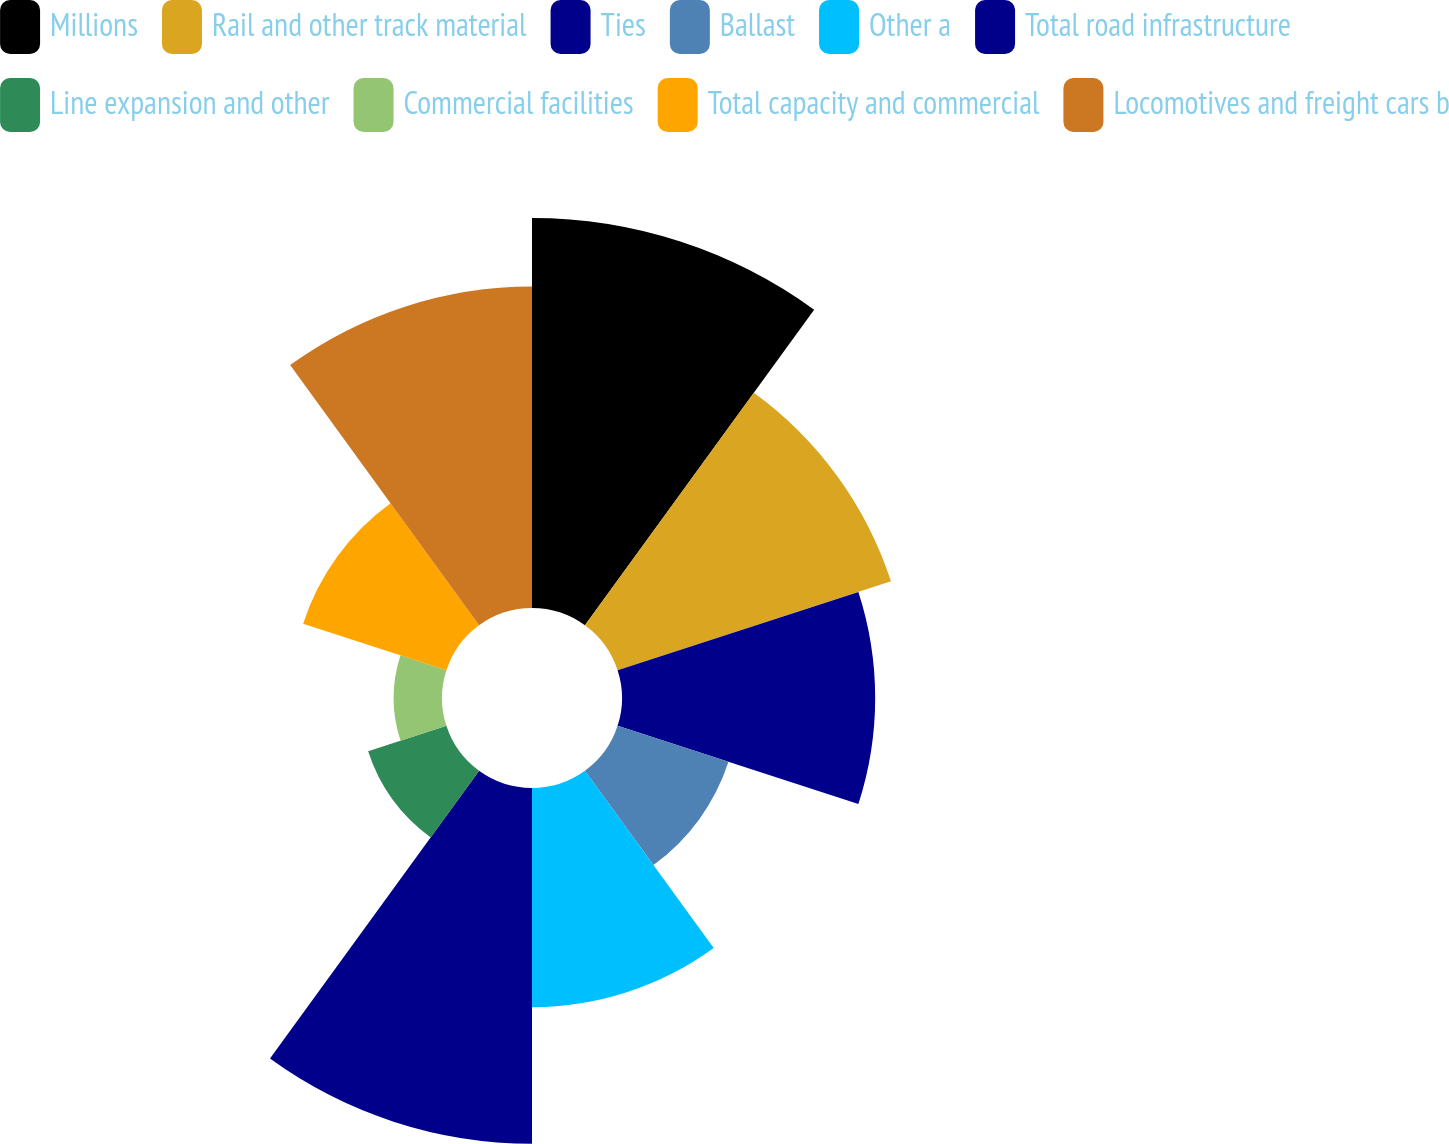<chart> <loc_0><loc_0><loc_500><loc_500><pie_chart><fcel>Millions<fcel>Rail and other track material<fcel>Ties<fcel>Ballast<fcel>Other a<fcel>Total road infrastructure<fcel>Line expansion and other<fcel>Commercial facilities<fcel>Total capacity and commercial<fcel>Locomotives and freight cars b<nl><fcel>17.53%<fcel>12.92%<fcel>11.38%<fcel>5.24%<fcel>9.85%<fcel>15.99%<fcel>3.7%<fcel>2.17%<fcel>6.77%<fcel>14.45%<nl></chart> 